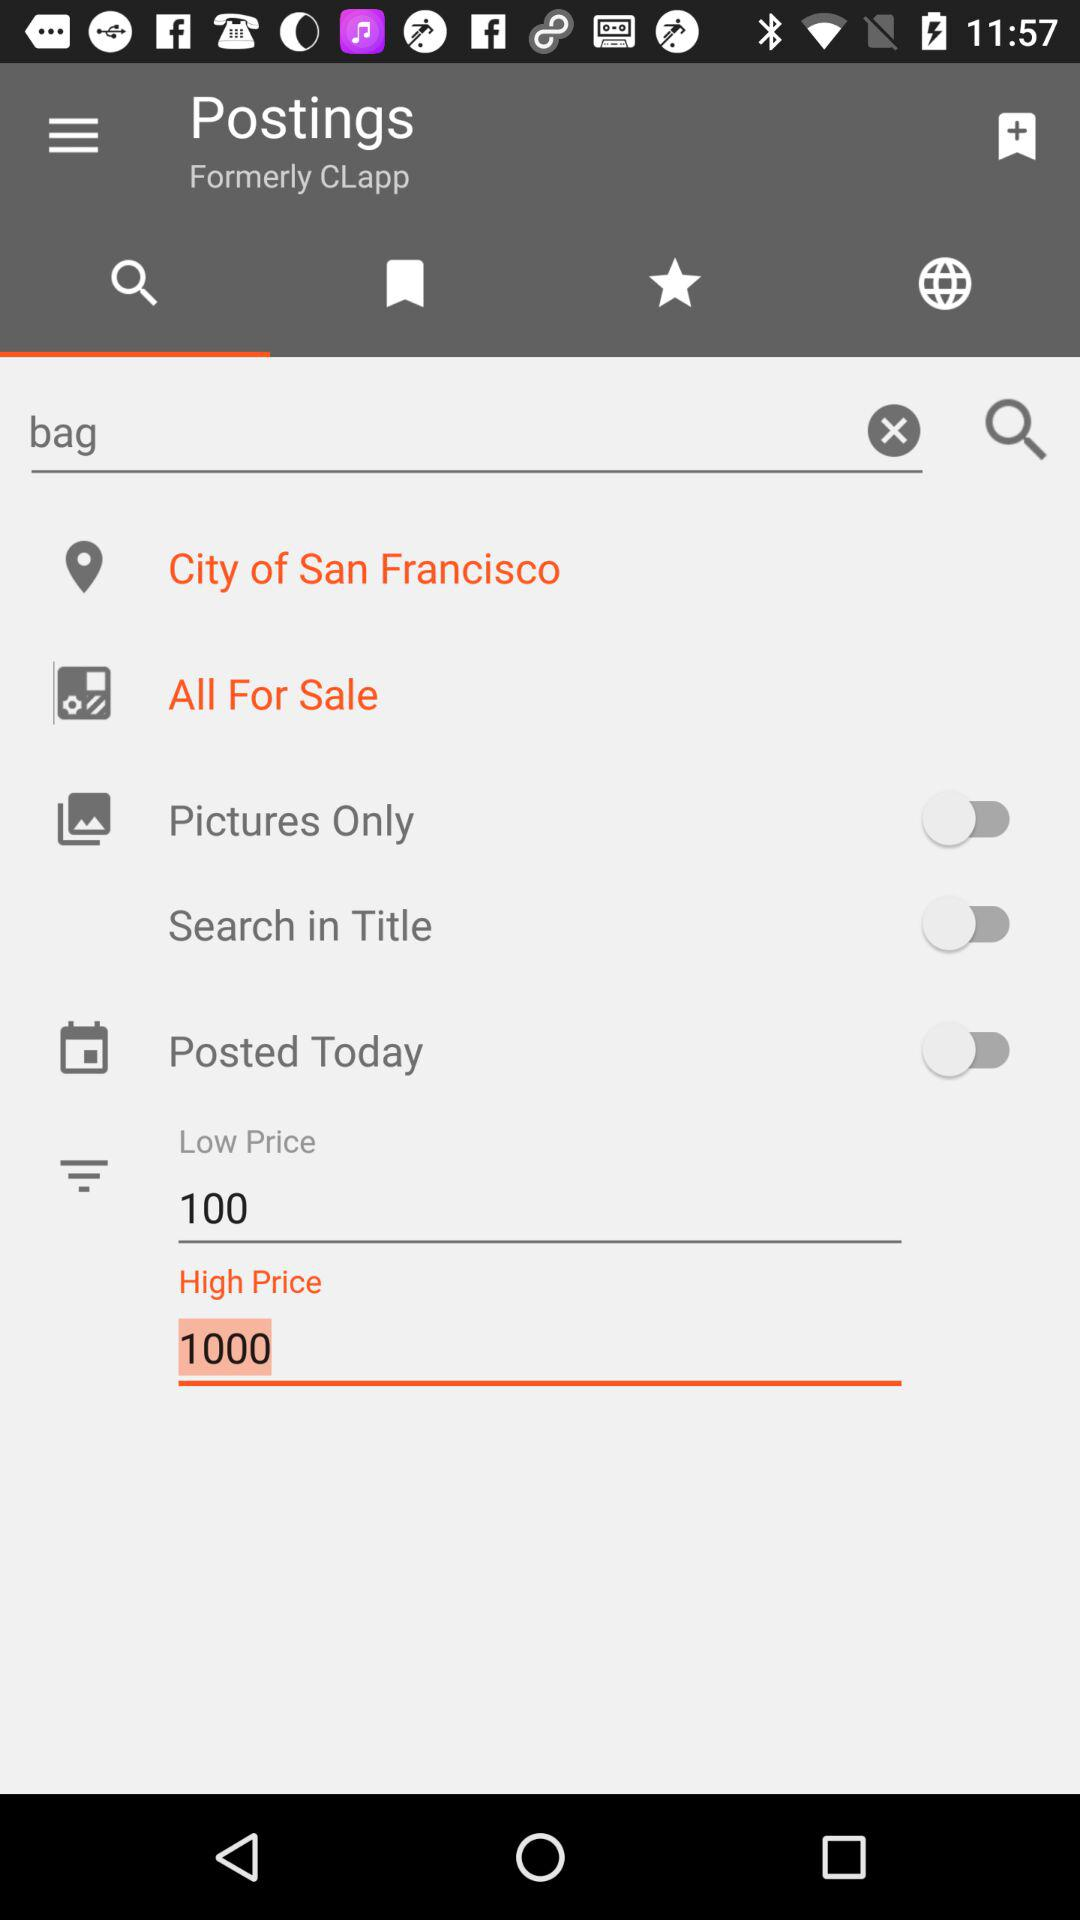What is the low price? The low price is 100. 